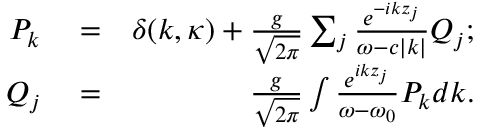<formula> <loc_0><loc_0><loc_500><loc_500>\begin{array} { r l r } { { P _ { k } } } & = } & { \delta ( { k , { \kappa } } ) + \frac { g } { { \sqrt { 2 \pi } } } \sum _ { j } { \frac { { { e ^ { - i k { z _ { j } } } } } } { \omega - c | k | } { Q _ { j } } } ; } \\ { { Q _ { j } } } & = } & { \frac { g } { { \sqrt { 2 \pi } } } \int { \frac { { { e ^ { i k { z _ { j } } } } } } { { \omega - { \omega _ { 0 } } } } { P _ { k } } d k } . } \end{array}</formula> 